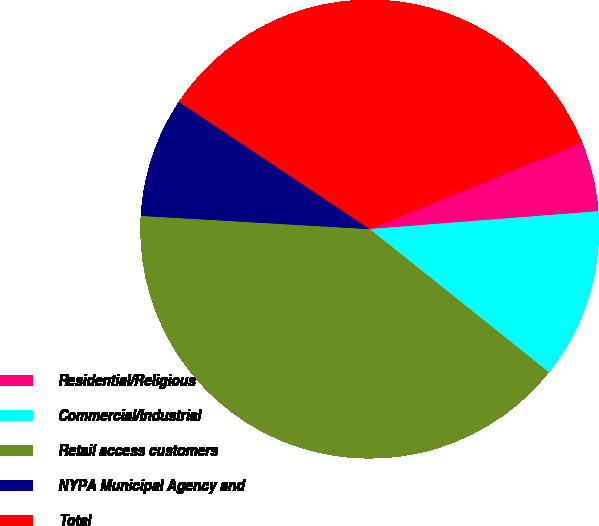<chart> <loc_0><loc_0><loc_500><loc_500><pie_chart><fcel>Residential/Religious<fcel>Commercial/Industrial<fcel>Retail access customers<fcel>NYPA Municipal Agency and<fcel>Total<nl><fcel>4.91%<fcel>11.97%<fcel>40.19%<fcel>8.44%<fcel>34.49%<nl></chart> 